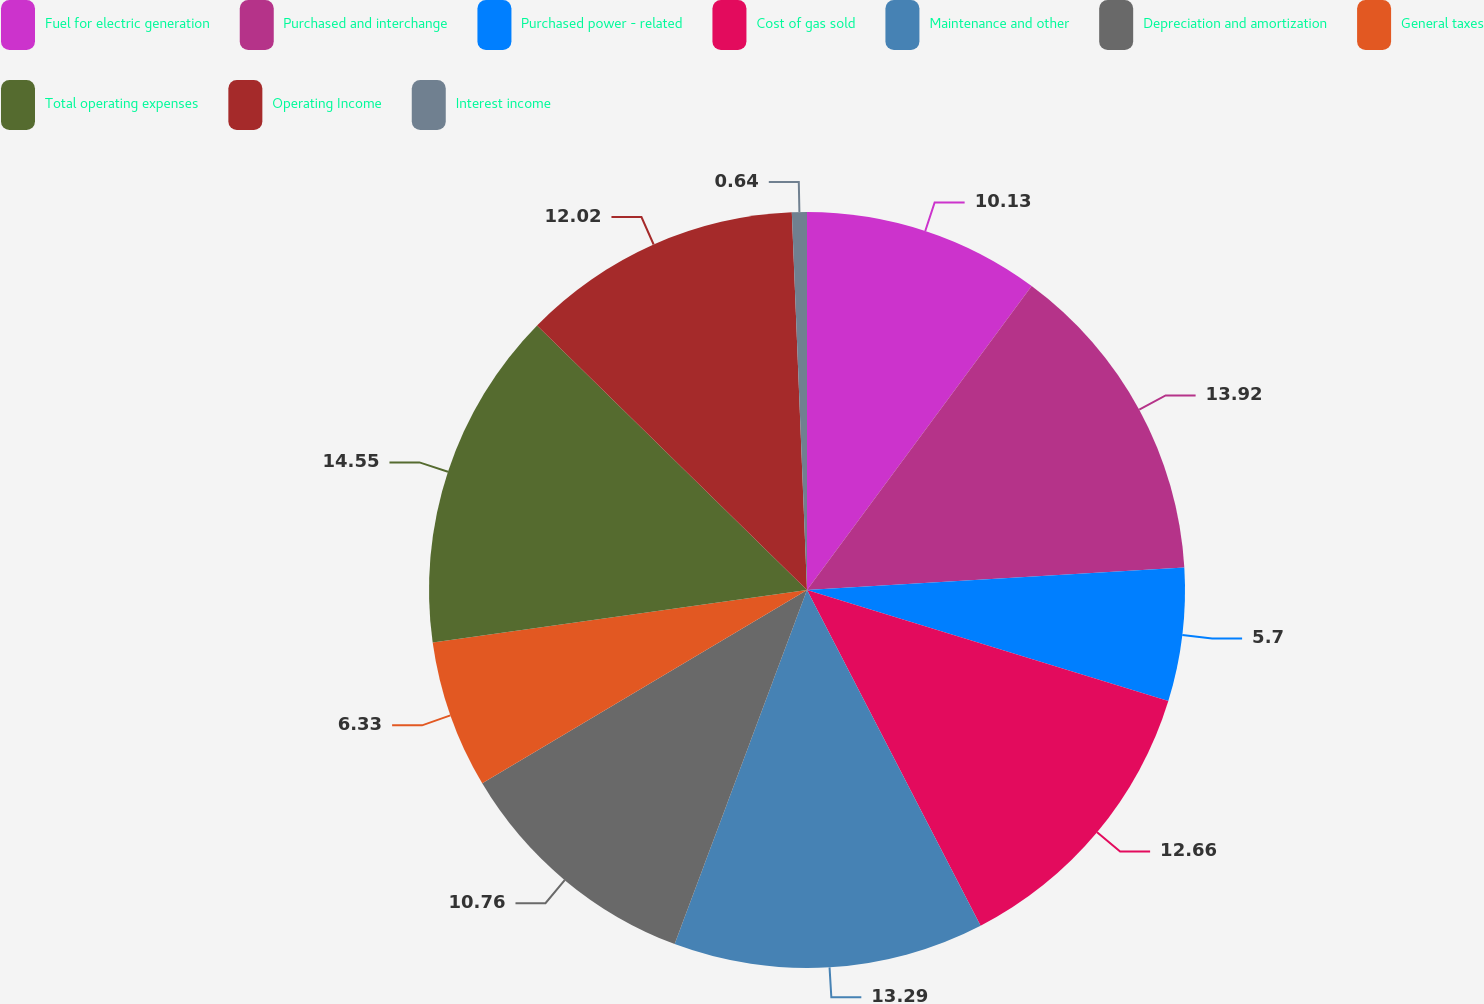<chart> <loc_0><loc_0><loc_500><loc_500><pie_chart><fcel>Fuel for electric generation<fcel>Purchased and interchange<fcel>Purchased power - related<fcel>Cost of gas sold<fcel>Maintenance and other<fcel>Depreciation and amortization<fcel>General taxes<fcel>Total operating expenses<fcel>Operating Income<fcel>Interest income<nl><fcel>10.13%<fcel>13.92%<fcel>5.7%<fcel>12.66%<fcel>13.29%<fcel>10.76%<fcel>6.33%<fcel>14.56%<fcel>12.02%<fcel>0.64%<nl></chart> 